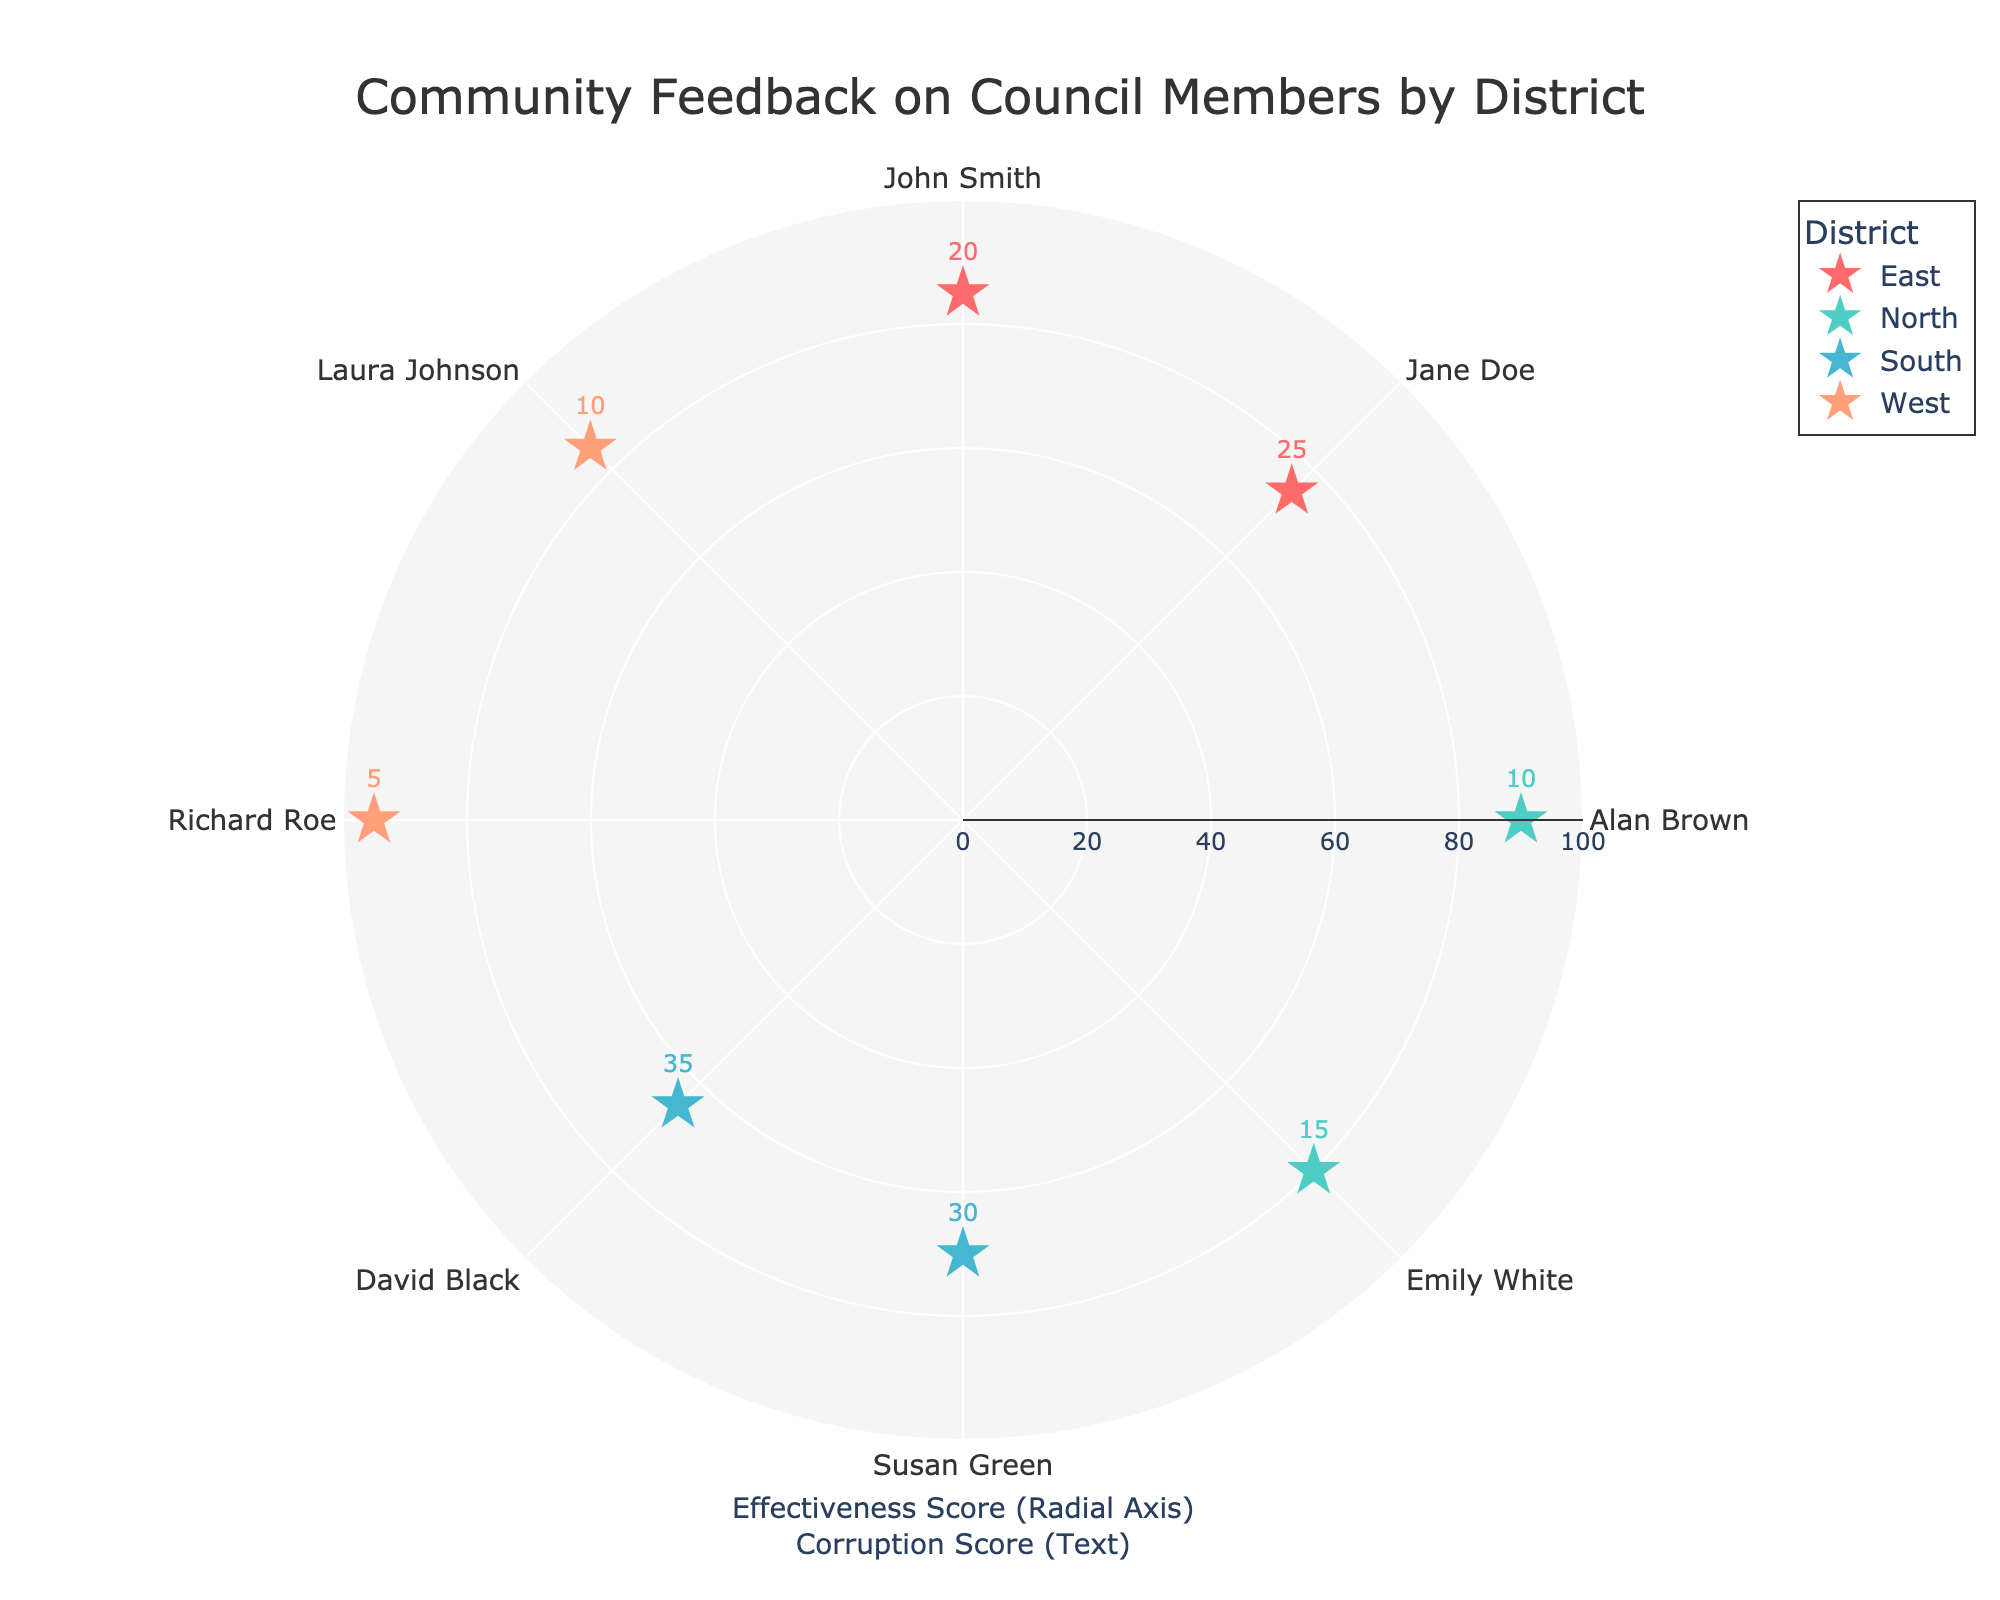What is the title of the Polar Scatter Chart? The title is found at the top center of the chart. It provides a quick overview of what the chart represents.
Answer: Community Feedback on Council Members by District How many council members are displayed for each district? The chart shows data points for council members within each district. Each point corresponds to a council member. There are two for each district: East, North, South, and West.
Answer: 2 Which district has the highest average effectiveness score? Calculate the average effectiveness score for each district and compare them. East: (85+75)/2=80, North: (90+80)/2=85, South: (70+65)/2=67.5, West: (95+85)/2=90.
Answer: West Which council member has the lowest corruption score? Compare the corruption scores written next to each data point. Richard Roe from the West district has a corruption score of 5, which is the lowest.
Answer: Richard Roe What is the color used to represent the East district? Each district is represented by a unique color. The East district is represented by a red color.
Answer: Red What is the difference in effectiveness scores between John Smith and Susan Green? John Smith has an effectiveness score of 85, and Susan Green has a score of 70. Subtract Susan's score from John's to find the difference. 85 - 70 = 15.
Answer: 15 How does Laura Johnson's effectiveness score compare to Jane Doe's? Laura Johnson has an effectiveness score of 85, while Jane Doe has a score of 75. Comparatively, Laura's score is higher by 10 points.
Answer: Higher by 10 Which council member from the North district has the lower corruption score? There are two council members in the North district. Compare Alan Brown (10) and Emily White (15) and identify the lower score.
Answer: Alan Brown What is the average corruption score for the South district? Add the corruption scores for Susan Green (30) and David Black (35) and divide by 2: (30 + 35)/2 = 32.5
Answer: 32.5 How does the West district's effectiveness scores compare to those of the East district? Compare the effectiveness scores of council members in both districts. The West district has scores of 95 and 85, while the East has scores of 85 and 75. Review both pairs and note that the West scores are higher.
Answer: Higher 